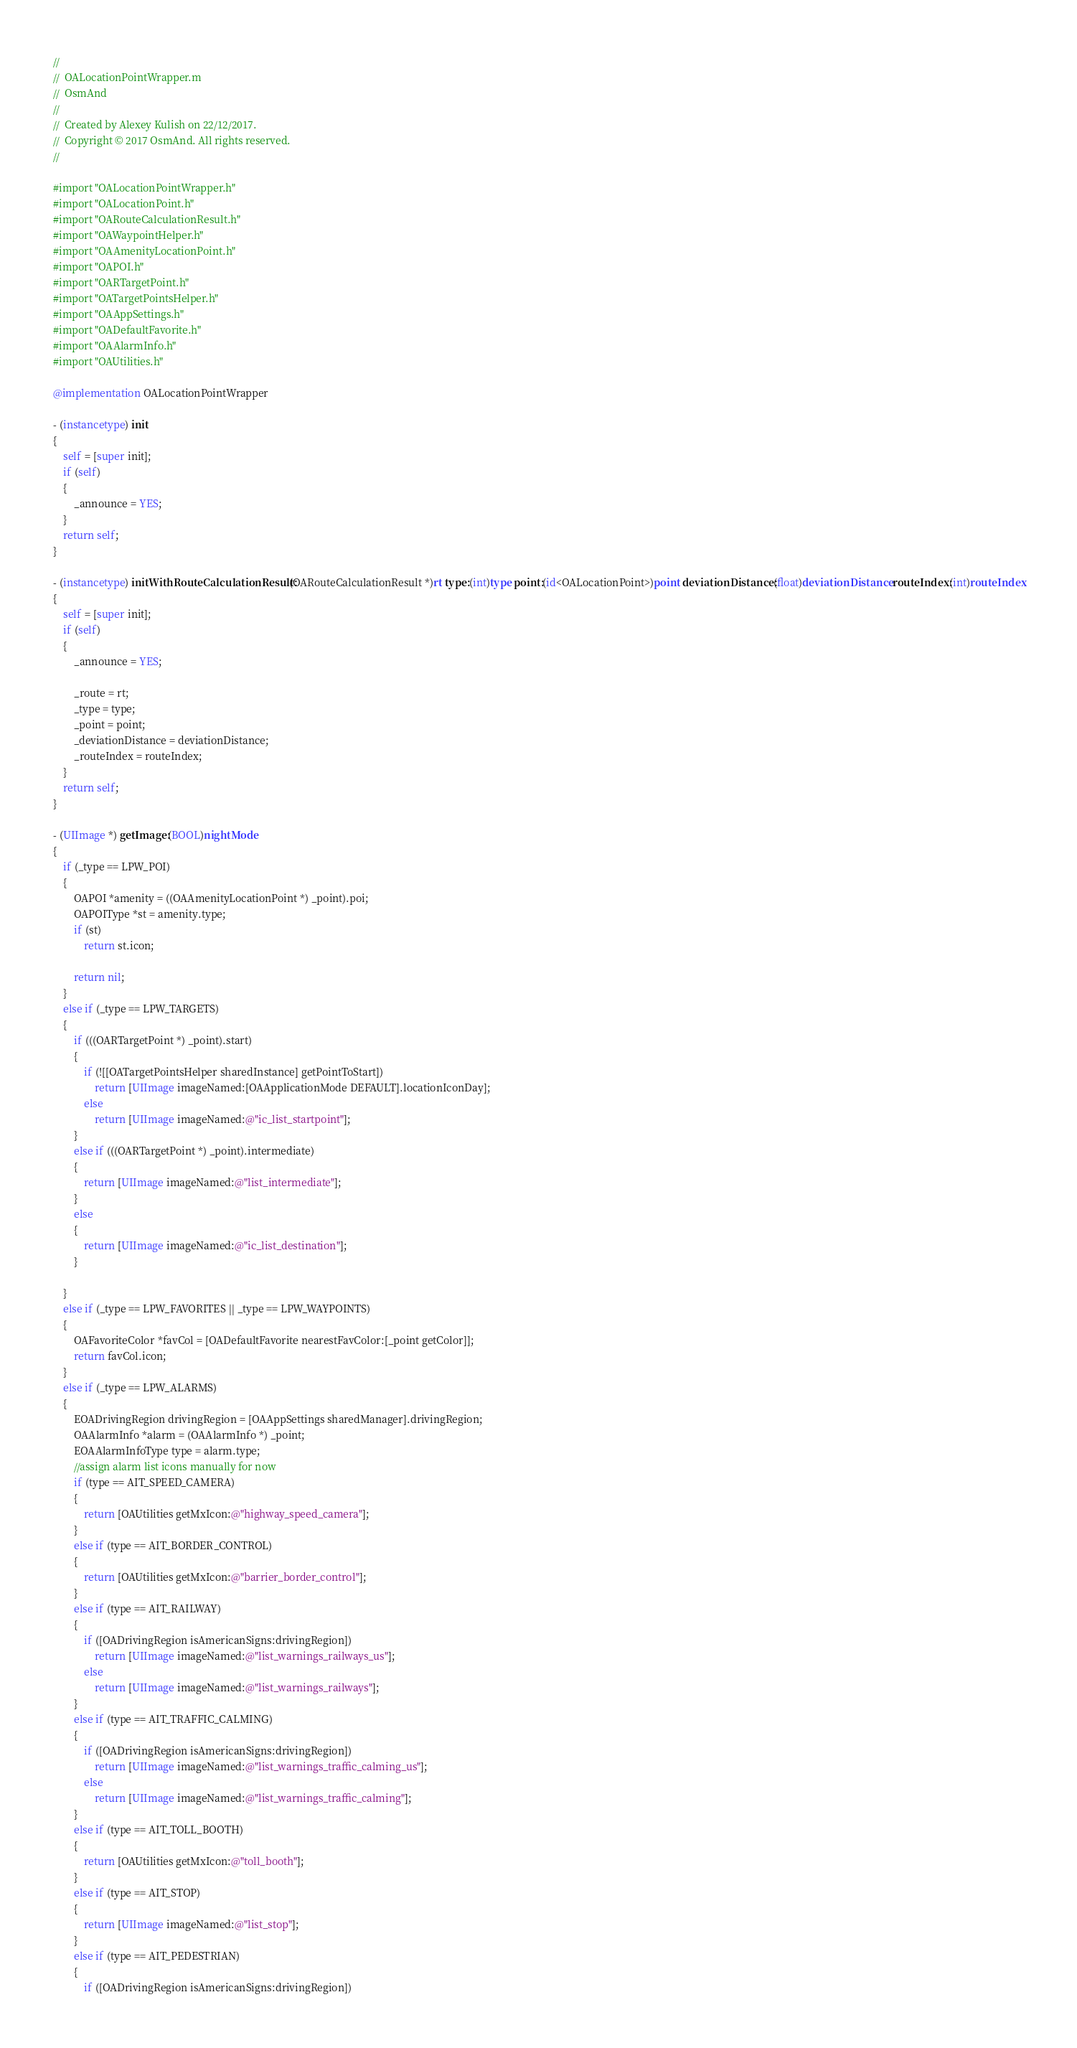Convert code to text. <code><loc_0><loc_0><loc_500><loc_500><_ObjectiveC_>//
//  OALocationPointWrapper.m
//  OsmAnd
//
//  Created by Alexey Kulish on 22/12/2017.
//  Copyright © 2017 OsmAnd. All rights reserved.
//

#import "OALocationPointWrapper.h"
#import "OALocationPoint.h"
#import "OARouteCalculationResult.h"
#import "OAWaypointHelper.h"
#import "OAAmenityLocationPoint.h"
#import "OAPOI.h"
#import "OARTargetPoint.h"
#import "OATargetPointsHelper.h"
#import "OAAppSettings.h"
#import "OADefaultFavorite.h"
#import "OAAlarmInfo.h"
#import "OAUtilities.h"

@implementation OALocationPointWrapper

- (instancetype) init
{
    self = [super init];
    if (self)
    {
        _announce = YES;
    }
    return self;
}

- (instancetype) initWithRouteCalculationResult:(OARouteCalculationResult *)rt type:(int)type point:(id<OALocationPoint>)point deviationDistance:(float)deviationDistance routeIndex:(int)routeIndex
{
    self = [super init];
    if (self)
    {
        _announce = YES;
        
        _route = rt;
        _type = type;
        _point = point;
        _deviationDistance = deviationDistance;
        _routeIndex = routeIndex;
    }
    return self;
}

- (UIImage *) getImage:(BOOL)nightMode
{
    if (_type == LPW_POI)
    {
        OAPOI *amenity = ((OAAmenityLocationPoint *) _point).poi;
        OAPOIType *st = amenity.type;
        if (st)
            return st.icon;

        return nil;
    }
    else if (_type == LPW_TARGETS)
    {
        if (((OARTargetPoint *) _point).start)
        {
            if (![[OATargetPointsHelper sharedInstance] getPointToStart])
                return [UIImage imageNamed:[OAApplicationMode DEFAULT].locationIconDay];
            else
                return [UIImage imageNamed:@"ic_list_startpoint"];
        }
        else if (((OARTargetPoint *) _point).intermediate)
        {
            return [UIImage imageNamed:@"list_intermediate"]; 
        }
        else
        {
            return [UIImage imageNamed:@"ic_list_destination"];
        }
        
    }
    else if (_type == LPW_FAVORITES || _type == LPW_WAYPOINTS)
    {
        OAFavoriteColor *favCol = [OADefaultFavorite nearestFavColor:[_point getColor]];
        return favCol.icon;
    }
    else if (_type == LPW_ALARMS)
    {
        EOADrivingRegion drivingRegion = [OAAppSettings sharedManager].drivingRegion;
        OAAlarmInfo *alarm = (OAAlarmInfo *) _point;
        EOAAlarmInfoType type = alarm.type;
        //assign alarm list icons manually for now
        if (type == AIT_SPEED_CAMERA)
        {
            return [OAUtilities getMxIcon:@"highway_speed_camera"];
        }
        else if (type == AIT_BORDER_CONTROL)
        {
            return [OAUtilities getMxIcon:@"barrier_border_control"];
        }
        else if (type == AIT_RAILWAY)
        {
            if ([OADrivingRegion isAmericanSigns:drivingRegion])
                return [UIImage imageNamed:@"list_warnings_railways_us"];
            else
                return [UIImage imageNamed:@"list_warnings_railways"];
        }
        else if (type == AIT_TRAFFIC_CALMING)
        {
            if ([OADrivingRegion isAmericanSigns:drivingRegion])
                return [UIImage imageNamed:@"list_warnings_traffic_calming_us"];
            else
                return [UIImage imageNamed:@"list_warnings_traffic_calming"];
        }
        else if (type == AIT_TOLL_BOOTH)
        {
            return [OAUtilities getMxIcon:@"toll_booth"];
        }
        else if (type == AIT_STOP)
        {
            return [UIImage imageNamed:@"list_stop"];
        }
        else if (type == AIT_PEDESTRIAN)
        {
            if ([OADrivingRegion isAmericanSigns:drivingRegion])</code> 